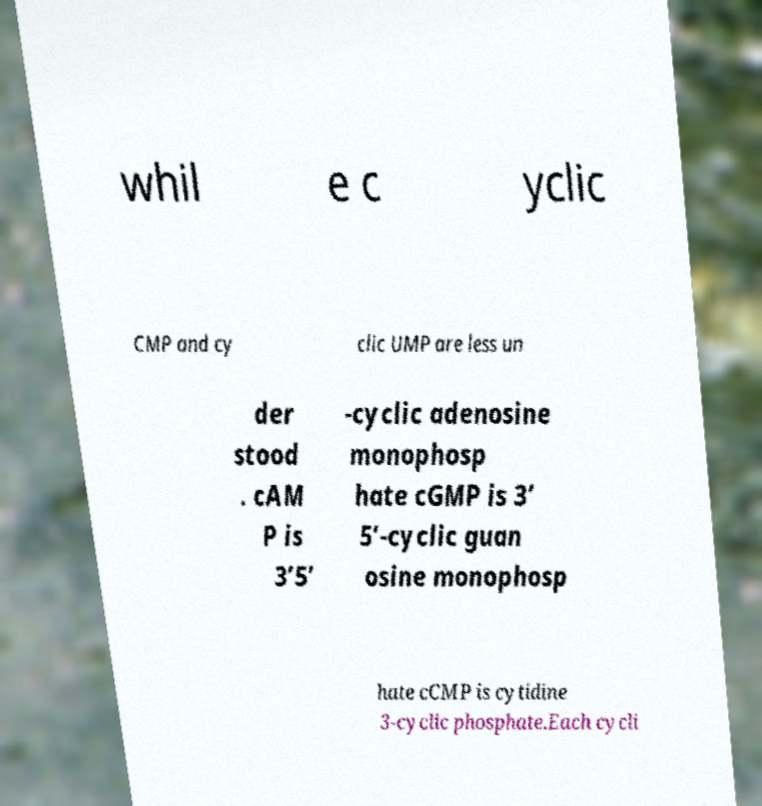Can you accurately transcribe the text from the provided image for me? whil e c yclic CMP and cy clic UMP are less un der stood . cAM P is 3’5’ -cyclic adenosine monophosp hate cGMP is 3’ 5’-cyclic guan osine monophosp hate cCMP is cytidine 3-cyclic phosphate.Each cycli 